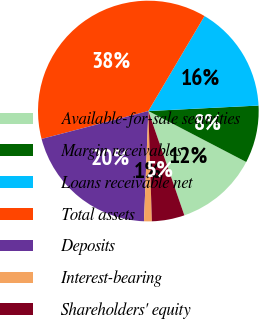<chart> <loc_0><loc_0><loc_500><loc_500><pie_chart><fcel>Available-for-sale securities<fcel>Margin receivables<fcel>Loans receivable net<fcel>Total assets<fcel>Deposits<fcel>Interest-bearing<fcel>Shareholders' equity<nl><fcel>12.07%<fcel>8.43%<fcel>15.71%<fcel>37.57%<fcel>20.3%<fcel>1.14%<fcel>4.78%<nl></chart> 